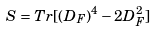<formula> <loc_0><loc_0><loc_500><loc_500>S = T r [ ( D _ { F } ) ^ { 4 } - 2 D _ { F } ^ { 2 } ]</formula> 